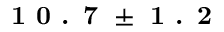Convert formula to latex. <formula><loc_0><loc_0><loc_500><loc_500>1 0 . 7 \pm 1 . 2</formula> 